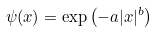<formula> <loc_0><loc_0><loc_500><loc_500>\psi ( x ) = \exp \left ( - a | x | ^ { b } \right )</formula> 